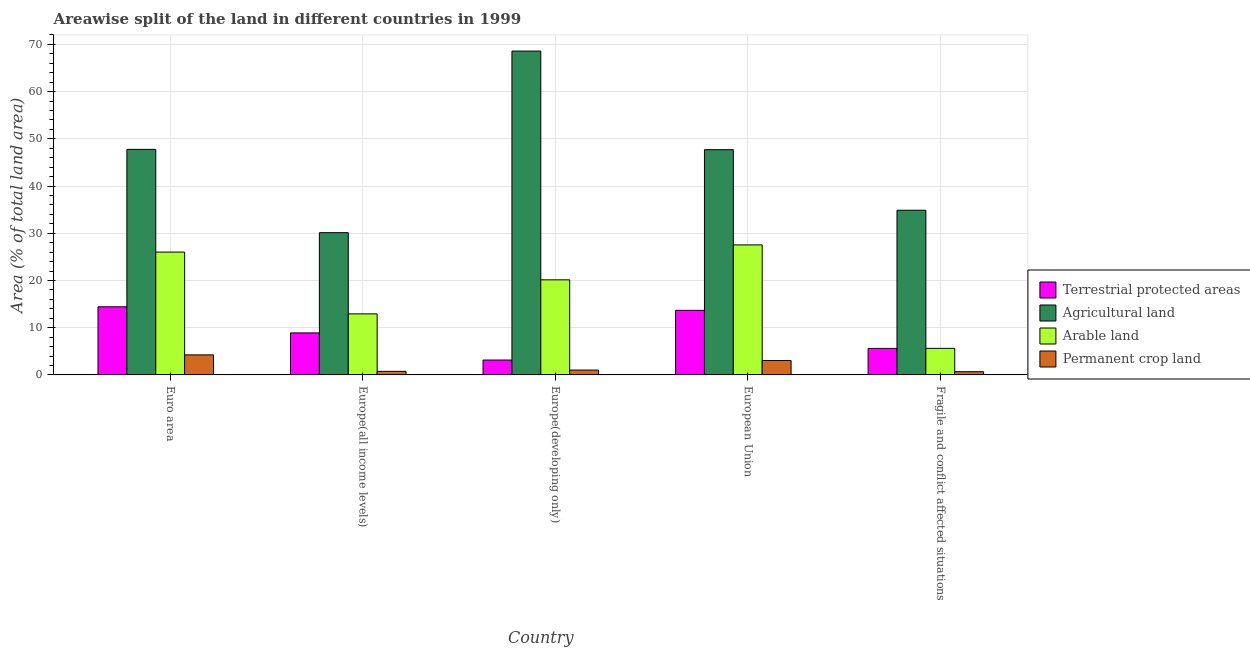How many bars are there on the 1st tick from the right?
Provide a short and direct response. 4. What is the label of the 4th group of bars from the left?
Keep it short and to the point. European Union. In how many cases, is the number of bars for a given country not equal to the number of legend labels?
Provide a succinct answer. 0. What is the percentage of area under agricultural land in Europe(all income levels)?
Provide a succinct answer. 30.12. Across all countries, what is the maximum percentage of area under agricultural land?
Provide a succinct answer. 68.58. Across all countries, what is the minimum percentage of area under permanent crop land?
Your response must be concise. 0.68. In which country was the percentage of area under agricultural land maximum?
Provide a succinct answer. Europe(developing only). In which country was the percentage of land under terrestrial protection minimum?
Your response must be concise. Europe(developing only). What is the total percentage of land under terrestrial protection in the graph?
Your answer should be compact. 45.75. What is the difference between the percentage of area under arable land in Europe(developing only) and that in European Union?
Keep it short and to the point. -7.4. What is the difference between the percentage of area under agricultural land in Euro area and the percentage of area under arable land in Europe(developing only)?
Offer a very short reply. 27.63. What is the average percentage of area under agricultural land per country?
Offer a very short reply. 45.81. What is the difference between the percentage of area under arable land and percentage of area under agricultural land in Europe(all income levels)?
Provide a short and direct response. -17.2. In how many countries, is the percentage of area under permanent crop land greater than 62 %?
Ensure brevity in your answer.  0. What is the ratio of the percentage of area under arable land in European Union to that in Fragile and conflict affected situations?
Keep it short and to the point. 4.89. Is the difference between the percentage of area under agricultural land in Europe(all income levels) and Fragile and conflict affected situations greater than the difference between the percentage of area under arable land in Europe(all income levels) and Fragile and conflict affected situations?
Your response must be concise. No. What is the difference between the highest and the second highest percentage of area under agricultural land?
Offer a terse response. 20.82. What is the difference between the highest and the lowest percentage of area under arable land?
Ensure brevity in your answer.  21.9. In how many countries, is the percentage of area under agricultural land greater than the average percentage of area under agricultural land taken over all countries?
Make the answer very short. 3. Is the sum of the percentage of area under agricultural land in Euro area and Fragile and conflict affected situations greater than the maximum percentage of area under permanent crop land across all countries?
Offer a very short reply. Yes. Is it the case that in every country, the sum of the percentage of area under agricultural land and percentage of land under terrestrial protection is greater than the sum of percentage of area under arable land and percentage of area under permanent crop land?
Your answer should be compact. Yes. What does the 1st bar from the left in Fragile and conflict affected situations represents?
Your response must be concise. Terrestrial protected areas. What does the 4th bar from the right in Fragile and conflict affected situations represents?
Keep it short and to the point. Terrestrial protected areas. Is it the case that in every country, the sum of the percentage of land under terrestrial protection and percentage of area under agricultural land is greater than the percentage of area under arable land?
Your response must be concise. Yes. Are all the bars in the graph horizontal?
Make the answer very short. No. What is the difference between two consecutive major ticks on the Y-axis?
Make the answer very short. 10. Are the values on the major ticks of Y-axis written in scientific E-notation?
Ensure brevity in your answer.  No. Does the graph contain grids?
Offer a terse response. Yes. Where does the legend appear in the graph?
Make the answer very short. Center right. How many legend labels are there?
Offer a terse response. 4. How are the legend labels stacked?
Keep it short and to the point. Vertical. What is the title of the graph?
Provide a succinct answer. Areawise split of the land in different countries in 1999. Does "Tertiary schools" appear as one of the legend labels in the graph?
Give a very brief answer. No. What is the label or title of the X-axis?
Offer a terse response. Country. What is the label or title of the Y-axis?
Give a very brief answer. Area (% of total land area). What is the Area (% of total land area) in Terrestrial protected areas in Euro area?
Your answer should be very brief. 14.42. What is the Area (% of total land area) in Agricultural land in Euro area?
Give a very brief answer. 47.76. What is the Area (% of total land area) of Arable land in Euro area?
Offer a very short reply. 26.01. What is the Area (% of total land area) of Permanent crop land in Euro area?
Keep it short and to the point. 4.24. What is the Area (% of total land area) of Terrestrial protected areas in Europe(all income levels)?
Provide a short and direct response. 8.89. What is the Area (% of total land area) of Agricultural land in Europe(all income levels)?
Provide a succinct answer. 30.12. What is the Area (% of total land area) of Arable land in Europe(all income levels)?
Offer a terse response. 12.92. What is the Area (% of total land area) of Permanent crop land in Europe(all income levels)?
Your answer should be very brief. 0.75. What is the Area (% of total land area) in Terrestrial protected areas in Europe(developing only)?
Your answer should be compact. 3.15. What is the Area (% of total land area) of Agricultural land in Europe(developing only)?
Keep it short and to the point. 68.58. What is the Area (% of total land area) in Arable land in Europe(developing only)?
Your answer should be very brief. 20.13. What is the Area (% of total land area) in Permanent crop land in Europe(developing only)?
Give a very brief answer. 1.03. What is the Area (% of total land area) of Terrestrial protected areas in European Union?
Your answer should be compact. 13.68. What is the Area (% of total land area) of Agricultural land in European Union?
Make the answer very short. 47.7. What is the Area (% of total land area) of Arable land in European Union?
Keep it short and to the point. 27.53. What is the Area (% of total land area) of Permanent crop land in European Union?
Give a very brief answer. 3.05. What is the Area (% of total land area) in Terrestrial protected areas in Fragile and conflict affected situations?
Offer a terse response. 5.61. What is the Area (% of total land area) of Agricultural land in Fragile and conflict affected situations?
Offer a terse response. 34.87. What is the Area (% of total land area) in Arable land in Fragile and conflict affected situations?
Offer a terse response. 5.63. What is the Area (% of total land area) in Permanent crop land in Fragile and conflict affected situations?
Ensure brevity in your answer.  0.68. Across all countries, what is the maximum Area (% of total land area) of Terrestrial protected areas?
Offer a terse response. 14.42. Across all countries, what is the maximum Area (% of total land area) of Agricultural land?
Give a very brief answer. 68.58. Across all countries, what is the maximum Area (% of total land area) in Arable land?
Ensure brevity in your answer.  27.53. Across all countries, what is the maximum Area (% of total land area) of Permanent crop land?
Keep it short and to the point. 4.24. Across all countries, what is the minimum Area (% of total land area) of Terrestrial protected areas?
Keep it short and to the point. 3.15. Across all countries, what is the minimum Area (% of total land area) of Agricultural land?
Make the answer very short. 30.12. Across all countries, what is the minimum Area (% of total land area) in Arable land?
Your answer should be very brief. 5.63. Across all countries, what is the minimum Area (% of total land area) in Permanent crop land?
Provide a succinct answer. 0.68. What is the total Area (% of total land area) in Terrestrial protected areas in the graph?
Provide a short and direct response. 45.75. What is the total Area (% of total land area) in Agricultural land in the graph?
Give a very brief answer. 229.03. What is the total Area (% of total land area) of Arable land in the graph?
Your answer should be very brief. 92.22. What is the total Area (% of total land area) in Permanent crop land in the graph?
Provide a short and direct response. 9.75. What is the difference between the Area (% of total land area) of Terrestrial protected areas in Euro area and that in Europe(all income levels)?
Your response must be concise. 5.53. What is the difference between the Area (% of total land area) in Agricultural land in Euro area and that in Europe(all income levels)?
Provide a short and direct response. 17.63. What is the difference between the Area (% of total land area) of Arable land in Euro area and that in Europe(all income levels)?
Offer a terse response. 13.09. What is the difference between the Area (% of total land area) in Permanent crop land in Euro area and that in Europe(all income levels)?
Your response must be concise. 3.49. What is the difference between the Area (% of total land area) of Terrestrial protected areas in Euro area and that in Europe(developing only)?
Make the answer very short. 11.27. What is the difference between the Area (% of total land area) of Agricultural land in Euro area and that in Europe(developing only)?
Give a very brief answer. -20.82. What is the difference between the Area (% of total land area) in Arable land in Euro area and that in Europe(developing only)?
Offer a very short reply. 5.88. What is the difference between the Area (% of total land area) in Permanent crop land in Euro area and that in Europe(developing only)?
Keep it short and to the point. 3.22. What is the difference between the Area (% of total land area) in Terrestrial protected areas in Euro area and that in European Union?
Provide a succinct answer. 0.75. What is the difference between the Area (% of total land area) of Agricultural land in Euro area and that in European Union?
Provide a succinct answer. 0.06. What is the difference between the Area (% of total land area) in Arable land in Euro area and that in European Union?
Your answer should be compact. -1.52. What is the difference between the Area (% of total land area) in Permanent crop land in Euro area and that in European Union?
Ensure brevity in your answer.  1.19. What is the difference between the Area (% of total land area) in Terrestrial protected areas in Euro area and that in Fragile and conflict affected situations?
Your answer should be very brief. 8.81. What is the difference between the Area (% of total land area) of Agricultural land in Euro area and that in Fragile and conflict affected situations?
Your answer should be compact. 12.89. What is the difference between the Area (% of total land area) of Arable land in Euro area and that in Fragile and conflict affected situations?
Keep it short and to the point. 20.39. What is the difference between the Area (% of total land area) in Permanent crop land in Euro area and that in Fragile and conflict affected situations?
Provide a short and direct response. 3.56. What is the difference between the Area (% of total land area) of Terrestrial protected areas in Europe(all income levels) and that in Europe(developing only)?
Make the answer very short. 5.74. What is the difference between the Area (% of total land area) in Agricultural land in Europe(all income levels) and that in Europe(developing only)?
Your response must be concise. -38.46. What is the difference between the Area (% of total land area) of Arable land in Europe(all income levels) and that in Europe(developing only)?
Keep it short and to the point. -7.21. What is the difference between the Area (% of total land area) in Permanent crop land in Europe(all income levels) and that in Europe(developing only)?
Offer a terse response. -0.27. What is the difference between the Area (% of total land area) in Terrestrial protected areas in Europe(all income levels) and that in European Union?
Your answer should be very brief. -4.78. What is the difference between the Area (% of total land area) in Agricultural land in Europe(all income levels) and that in European Union?
Make the answer very short. -17.57. What is the difference between the Area (% of total land area) of Arable land in Europe(all income levels) and that in European Union?
Keep it short and to the point. -14.61. What is the difference between the Area (% of total land area) of Permanent crop land in Europe(all income levels) and that in European Union?
Keep it short and to the point. -2.29. What is the difference between the Area (% of total land area) in Terrestrial protected areas in Europe(all income levels) and that in Fragile and conflict affected situations?
Your answer should be very brief. 3.28. What is the difference between the Area (% of total land area) of Agricultural land in Europe(all income levels) and that in Fragile and conflict affected situations?
Give a very brief answer. -4.75. What is the difference between the Area (% of total land area) of Arable land in Europe(all income levels) and that in Fragile and conflict affected situations?
Provide a succinct answer. 7.3. What is the difference between the Area (% of total land area) of Permanent crop land in Europe(all income levels) and that in Fragile and conflict affected situations?
Ensure brevity in your answer.  0.08. What is the difference between the Area (% of total land area) in Terrestrial protected areas in Europe(developing only) and that in European Union?
Offer a terse response. -10.52. What is the difference between the Area (% of total land area) of Agricultural land in Europe(developing only) and that in European Union?
Provide a short and direct response. 20.88. What is the difference between the Area (% of total land area) in Arable land in Europe(developing only) and that in European Union?
Keep it short and to the point. -7.4. What is the difference between the Area (% of total land area) of Permanent crop land in Europe(developing only) and that in European Union?
Your answer should be compact. -2.02. What is the difference between the Area (% of total land area) of Terrestrial protected areas in Europe(developing only) and that in Fragile and conflict affected situations?
Ensure brevity in your answer.  -2.46. What is the difference between the Area (% of total land area) of Agricultural land in Europe(developing only) and that in Fragile and conflict affected situations?
Give a very brief answer. 33.71. What is the difference between the Area (% of total land area) in Arable land in Europe(developing only) and that in Fragile and conflict affected situations?
Give a very brief answer. 14.51. What is the difference between the Area (% of total land area) in Permanent crop land in Europe(developing only) and that in Fragile and conflict affected situations?
Ensure brevity in your answer.  0.35. What is the difference between the Area (% of total land area) in Terrestrial protected areas in European Union and that in Fragile and conflict affected situations?
Make the answer very short. 8.06. What is the difference between the Area (% of total land area) of Agricultural land in European Union and that in Fragile and conflict affected situations?
Provide a succinct answer. 12.83. What is the difference between the Area (% of total land area) of Arable land in European Union and that in Fragile and conflict affected situations?
Give a very brief answer. 21.9. What is the difference between the Area (% of total land area) of Permanent crop land in European Union and that in Fragile and conflict affected situations?
Offer a very short reply. 2.37. What is the difference between the Area (% of total land area) of Terrestrial protected areas in Euro area and the Area (% of total land area) of Agricultural land in Europe(all income levels)?
Offer a very short reply. -15.7. What is the difference between the Area (% of total land area) of Terrestrial protected areas in Euro area and the Area (% of total land area) of Permanent crop land in Europe(all income levels)?
Offer a terse response. 13.67. What is the difference between the Area (% of total land area) in Agricultural land in Euro area and the Area (% of total land area) in Arable land in Europe(all income levels)?
Offer a very short reply. 34.84. What is the difference between the Area (% of total land area) of Agricultural land in Euro area and the Area (% of total land area) of Permanent crop land in Europe(all income levels)?
Offer a terse response. 47.01. What is the difference between the Area (% of total land area) in Arable land in Euro area and the Area (% of total land area) in Permanent crop land in Europe(all income levels)?
Provide a short and direct response. 25.26. What is the difference between the Area (% of total land area) of Terrestrial protected areas in Euro area and the Area (% of total land area) of Agricultural land in Europe(developing only)?
Offer a very short reply. -54.16. What is the difference between the Area (% of total land area) in Terrestrial protected areas in Euro area and the Area (% of total land area) in Arable land in Europe(developing only)?
Make the answer very short. -5.71. What is the difference between the Area (% of total land area) in Terrestrial protected areas in Euro area and the Area (% of total land area) in Permanent crop land in Europe(developing only)?
Your answer should be very brief. 13.4. What is the difference between the Area (% of total land area) in Agricultural land in Euro area and the Area (% of total land area) in Arable land in Europe(developing only)?
Make the answer very short. 27.63. What is the difference between the Area (% of total land area) of Agricultural land in Euro area and the Area (% of total land area) of Permanent crop land in Europe(developing only)?
Ensure brevity in your answer.  46.73. What is the difference between the Area (% of total land area) of Arable land in Euro area and the Area (% of total land area) of Permanent crop land in Europe(developing only)?
Keep it short and to the point. 24.99. What is the difference between the Area (% of total land area) of Terrestrial protected areas in Euro area and the Area (% of total land area) of Agricultural land in European Union?
Your response must be concise. -33.28. What is the difference between the Area (% of total land area) of Terrestrial protected areas in Euro area and the Area (% of total land area) of Arable land in European Union?
Make the answer very short. -13.11. What is the difference between the Area (% of total land area) of Terrestrial protected areas in Euro area and the Area (% of total land area) of Permanent crop land in European Union?
Ensure brevity in your answer.  11.37. What is the difference between the Area (% of total land area) of Agricultural land in Euro area and the Area (% of total land area) of Arable land in European Union?
Keep it short and to the point. 20.23. What is the difference between the Area (% of total land area) of Agricultural land in Euro area and the Area (% of total land area) of Permanent crop land in European Union?
Give a very brief answer. 44.71. What is the difference between the Area (% of total land area) of Arable land in Euro area and the Area (% of total land area) of Permanent crop land in European Union?
Your response must be concise. 22.96. What is the difference between the Area (% of total land area) in Terrestrial protected areas in Euro area and the Area (% of total land area) in Agricultural land in Fragile and conflict affected situations?
Ensure brevity in your answer.  -20.45. What is the difference between the Area (% of total land area) in Terrestrial protected areas in Euro area and the Area (% of total land area) in Arable land in Fragile and conflict affected situations?
Ensure brevity in your answer.  8.8. What is the difference between the Area (% of total land area) of Terrestrial protected areas in Euro area and the Area (% of total land area) of Permanent crop land in Fragile and conflict affected situations?
Give a very brief answer. 13.74. What is the difference between the Area (% of total land area) of Agricultural land in Euro area and the Area (% of total land area) of Arable land in Fragile and conflict affected situations?
Provide a short and direct response. 42.13. What is the difference between the Area (% of total land area) in Agricultural land in Euro area and the Area (% of total land area) in Permanent crop land in Fragile and conflict affected situations?
Provide a short and direct response. 47.08. What is the difference between the Area (% of total land area) of Arable land in Euro area and the Area (% of total land area) of Permanent crop land in Fragile and conflict affected situations?
Ensure brevity in your answer.  25.33. What is the difference between the Area (% of total land area) in Terrestrial protected areas in Europe(all income levels) and the Area (% of total land area) in Agricultural land in Europe(developing only)?
Your answer should be very brief. -59.69. What is the difference between the Area (% of total land area) of Terrestrial protected areas in Europe(all income levels) and the Area (% of total land area) of Arable land in Europe(developing only)?
Make the answer very short. -11.24. What is the difference between the Area (% of total land area) in Terrestrial protected areas in Europe(all income levels) and the Area (% of total land area) in Permanent crop land in Europe(developing only)?
Keep it short and to the point. 7.87. What is the difference between the Area (% of total land area) of Agricultural land in Europe(all income levels) and the Area (% of total land area) of Arable land in Europe(developing only)?
Provide a succinct answer. 9.99. What is the difference between the Area (% of total land area) in Agricultural land in Europe(all income levels) and the Area (% of total land area) in Permanent crop land in Europe(developing only)?
Your answer should be compact. 29.1. What is the difference between the Area (% of total land area) of Arable land in Europe(all income levels) and the Area (% of total land area) of Permanent crop land in Europe(developing only)?
Offer a very short reply. 11.9. What is the difference between the Area (% of total land area) in Terrestrial protected areas in Europe(all income levels) and the Area (% of total land area) in Agricultural land in European Union?
Your response must be concise. -38.81. What is the difference between the Area (% of total land area) of Terrestrial protected areas in Europe(all income levels) and the Area (% of total land area) of Arable land in European Union?
Offer a very short reply. -18.64. What is the difference between the Area (% of total land area) of Terrestrial protected areas in Europe(all income levels) and the Area (% of total land area) of Permanent crop land in European Union?
Provide a succinct answer. 5.84. What is the difference between the Area (% of total land area) in Agricultural land in Europe(all income levels) and the Area (% of total land area) in Arable land in European Union?
Give a very brief answer. 2.6. What is the difference between the Area (% of total land area) of Agricultural land in Europe(all income levels) and the Area (% of total land area) of Permanent crop land in European Union?
Make the answer very short. 27.08. What is the difference between the Area (% of total land area) in Arable land in Europe(all income levels) and the Area (% of total land area) in Permanent crop land in European Union?
Offer a terse response. 9.87. What is the difference between the Area (% of total land area) of Terrestrial protected areas in Europe(all income levels) and the Area (% of total land area) of Agricultural land in Fragile and conflict affected situations?
Give a very brief answer. -25.98. What is the difference between the Area (% of total land area) in Terrestrial protected areas in Europe(all income levels) and the Area (% of total land area) in Arable land in Fragile and conflict affected situations?
Your answer should be compact. 3.27. What is the difference between the Area (% of total land area) in Terrestrial protected areas in Europe(all income levels) and the Area (% of total land area) in Permanent crop land in Fragile and conflict affected situations?
Your answer should be very brief. 8.22. What is the difference between the Area (% of total land area) of Agricultural land in Europe(all income levels) and the Area (% of total land area) of Arable land in Fragile and conflict affected situations?
Provide a short and direct response. 24.5. What is the difference between the Area (% of total land area) of Agricultural land in Europe(all income levels) and the Area (% of total land area) of Permanent crop land in Fragile and conflict affected situations?
Keep it short and to the point. 29.45. What is the difference between the Area (% of total land area) in Arable land in Europe(all income levels) and the Area (% of total land area) in Permanent crop land in Fragile and conflict affected situations?
Provide a short and direct response. 12.24. What is the difference between the Area (% of total land area) of Terrestrial protected areas in Europe(developing only) and the Area (% of total land area) of Agricultural land in European Union?
Your answer should be compact. -44.55. What is the difference between the Area (% of total land area) in Terrestrial protected areas in Europe(developing only) and the Area (% of total land area) in Arable land in European Union?
Your answer should be very brief. -24.38. What is the difference between the Area (% of total land area) of Terrestrial protected areas in Europe(developing only) and the Area (% of total land area) of Permanent crop land in European Union?
Offer a very short reply. 0.1. What is the difference between the Area (% of total land area) of Agricultural land in Europe(developing only) and the Area (% of total land area) of Arable land in European Union?
Provide a short and direct response. 41.05. What is the difference between the Area (% of total land area) of Agricultural land in Europe(developing only) and the Area (% of total land area) of Permanent crop land in European Union?
Provide a short and direct response. 65.53. What is the difference between the Area (% of total land area) of Arable land in Europe(developing only) and the Area (% of total land area) of Permanent crop land in European Union?
Keep it short and to the point. 17.08. What is the difference between the Area (% of total land area) in Terrestrial protected areas in Europe(developing only) and the Area (% of total land area) in Agricultural land in Fragile and conflict affected situations?
Keep it short and to the point. -31.72. What is the difference between the Area (% of total land area) in Terrestrial protected areas in Europe(developing only) and the Area (% of total land area) in Arable land in Fragile and conflict affected situations?
Keep it short and to the point. -2.48. What is the difference between the Area (% of total land area) in Terrestrial protected areas in Europe(developing only) and the Area (% of total land area) in Permanent crop land in Fragile and conflict affected situations?
Make the answer very short. 2.47. What is the difference between the Area (% of total land area) of Agricultural land in Europe(developing only) and the Area (% of total land area) of Arable land in Fragile and conflict affected situations?
Keep it short and to the point. 62.95. What is the difference between the Area (% of total land area) of Agricultural land in Europe(developing only) and the Area (% of total land area) of Permanent crop land in Fragile and conflict affected situations?
Ensure brevity in your answer.  67.9. What is the difference between the Area (% of total land area) of Arable land in Europe(developing only) and the Area (% of total land area) of Permanent crop land in Fragile and conflict affected situations?
Your response must be concise. 19.46. What is the difference between the Area (% of total land area) of Terrestrial protected areas in European Union and the Area (% of total land area) of Agricultural land in Fragile and conflict affected situations?
Your response must be concise. -21.2. What is the difference between the Area (% of total land area) in Terrestrial protected areas in European Union and the Area (% of total land area) in Arable land in Fragile and conflict affected situations?
Your response must be concise. 8.05. What is the difference between the Area (% of total land area) in Terrestrial protected areas in European Union and the Area (% of total land area) in Permanent crop land in Fragile and conflict affected situations?
Offer a terse response. 13. What is the difference between the Area (% of total land area) of Agricultural land in European Union and the Area (% of total land area) of Arable land in Fragile and conflict affected situations?
Provide a succinct answer. 42.07. What is the difference between the Area (% of total land area) in Agricultural land in European Union and the Area (% of total land area) in Permanent crop land in Fragile and conflict affected situations?
Offer a terse response. 47.02. What is the difference between the Area (% of total land area) in Arable land in European Union and the Area (% of total land area) in Permanent crop land in Fragile and conflict affected situations?
Your answer should be very brief. 26.85. What is the average Area (% of total land area) in Terrestrial protected areas per country?
Offer a terse response. 9.15. What is the average Area (% of total land area) of Agricultural land per country?
Offer a very short reply. 45.81. What is the average Area (% of total land area) of Arable land per country?
Offer a terse response. 18.44. What is the average Area (% of total land area) of Permanent crop land per country?
Provide a succinct answer. 1.95. What is the difference between the Area (% of total land area) in Terrestrial protected areas and Area (% of total land area) in Agricultural land in Euro area?
Your response must be concise. -33.34. What is the difference between the Area (% of total land area) in Terrestrial protected areas and Area (% of total land area) in Arable land in Euro area?
Ensure brevity in your answer.  -11.59. What is the difference between the Area (% of total land area) in Terrestrial protected areas and Area (% of total land area) in Permanent crop land in Euro area?
Your answer should be very brief. 10.18. What is the difference between the Area (% of total land area) of Agricultural land and Area (% of total land area) of Arable land in Euro area?
Offer a terse response. 21.75. What is the difference between the Area (% of total land area) in Agricultural land and Area (% of total land area) in Permanent crop land in Euro area?
Your answer should be very brief. 43.52. What is the difference between the Area (% of total land area) in Arable land and Area (% of total land area) in Permanent crop land in Euro area?
Provide a succinct answer. 21.77. What is the difference between the Area (% of total land area) of Terrestrial protected areas and Area (% of total land area) of Agricultural land in Europe(all income levels)?
Ensure brevity in your answer.  -21.23. What is the difference between the Area (% of total land area) of Terrestrial protected areas and Area (% of total land area) of Arable land in Europe(all income levels)?
Offer a very short reply. -4.03. What is the difference between the Area (% of total land area) in Terrestrial protected areas and Area (% of total land area) in Permanent crop land in Europe(all income levels)?
Your response must be concise. 8.14. What is the difference between the Area (% of total land area) of Agricultural land and Area (% of total land area) of Arable land in Europe(all income levels)?
Provide a short and direct response. 17.2. What is the difference between the Area (% of total land area) in Agricultural land and Area (% of total land area) in Permanent crop land in Europe(all income levels)?
Offer a very short reply. 29.37. What is the difference between the Area (% of total land area) in Arable land and Area (% of total land area) in Permanent crop land in Europe(all income levels)?
Keep it short and to the point. 12.17. What is the difference between the Area (% of total land area) of Terrestrial protected areas and Area (% of total land area) of Agricultural land in Europe(developing only)?
Ensure brevity in your answer.  -65.43. What is the difference between the Area (% of total land area) of Terrestrial protected areas and Area (% of total land area) of Arable land in Europe(developing only)?
Make the answer very short. -16.98. What is the difference between the Area (% of total land area) in Terrestrial protected areas and Area (% of total land area) in Permanent crop land in Europe(developing only)?
Your answer should be compact. 2.12. What is the difference between the Area (% of total land area) in Agricultural land and Area (% of total land area) in Arable land in Europe(developing only)?
Provide a short and direct response. 48.45. What is the difference between the Area (% of total land area) in Agricultural land and Area (% of total land area) in Permanent crop land in Europe(developing only)?
Provide a short and direct response. 67.55. What is the difference between the Area (% of total land area) in Arable land and Area (% of total land area) in Permanent crop land in Europe(developing only)?
Your answer should be very brief. 19.11. What is the difference between the Area (% of total land area) of Terrestrial protected areas and Area (% of total land area) of Agricultural land in European Union?
Your answer should be very brief. -34.02. What is the difference between the Area (% of total land area) of Terrestrial protected areas and Area (% of total land area) of Arable land in European Union?
Ensure brevity in your answer.  -13.85. What is the difference between the Area (% of total land area) of Terrestrial protected areas and Area (% of total land area) of Permanent crop land in European Union?
Make the answer very short. 10.63. What is the difference between the Area (% of total land area) in Agricultural land and Area (% of total land area) in Arable land in European Union?
Your response must be concise. 20.17. What is the difference between the Area (% of total land area) in Agricultural land and Area (% of total land area) in Permanent crop land in European Union?
Your response must be concise. 44.65. What is the difference between the Area (% of total land area) of Arable land and Area (% of total land area) of Permanent crop land in European Union?
Your response must be concise. 24.48. What is the difference between the Area (% of total land area) in Terrestrial protected areas and Area (% of total land area) in Agricultural land in Fragile and conflict affected situations?
Keep it short and to the point. -29.26. What is the difference between the Area (% of total land area) in Terrestrial protected areas and Area (% of total land area) in Arable land in Fragile and conflict affected situations?
Offer a terse response. -0.01. What is the difference between the Area (% of total land area) in Terrestrial protected areas and Area (% of total land area) in Permanent crop land in Fragile and conflict affected situations?
Offer a terse response. 4.94. What is the difference between the Area (% of total land area) of Agricultural land and Area (% of total land area) of Arable land in Fragile and conflict affected situations?
Your answer should be very brief. 29.24. What is the difference between the Area (% of total land area) in Agricultural land and Area (% of total land area) in Permanent crop land in Fragile and conflict affected situations?
Ensure brevity in your answer.  34.19. What is the difference between the Area (% of total land area) in Arable land and Area (% of total land area) in Permanent crop land in Fragile and conflict affected situations?
Give a very brief answer. 4.95. What is the ratio of the Area (% of total land area) in Terrestrial protected areas in Euro area to that in Europe(all income levels)?
Make the answer very short. 1.62. What is the ratio of the Area (% of total land area) of Agricultural land in Euro area to that in Europe(all income levels)?
Provide a succinct answer. 1.59. What is the ratio of the Area (% of total land area) in Arable land in Euro area to that in Europe(all income levels)?
Ensure brevity in your answer.  2.01. What is the ratio of the Area (% of total land area) of Permanent crop land in Euro area to that in Europe(all income levels)?
Your answer should be very brief. 5.62. What is the ratio of the Area (% of total land area) in Terrestrial protected areas in Euro area to that in Europe(developing only)?
Provide a short and direct response. 4.58. What is the ratio of the Area (% of total land area) in Agricultural land in Euro area to that in Europe(developing only)?
Provide a short and direct response. 0.7. What is the ratio of the Area (% of total land area) in Arable land in Euro area to that in Europe(developing only)?
Provide a succinct answer. 1.29. What is the ratio of the Area (% of total land area) of Permanent crop land in Euro area to that in Europe(developing only)?
Your answer should be compact. 4.13. What is the ratio of the Area (% of total land area) of Terrestrial protected areas in Euro area to that in European Union?
Your answer should be very brief. 1.05. What is the ratio of the Area (% of total land area) of Agricultural land in Euro area to that in European Union?
Ensure brevity in your answer.  1. What is the ratio of the Area (% of total land area) of Arable land in Euro area to that in European Union?
Your response must be concise. 0.94. What is the ratio of the Area (% of total land area) in Permanent crop land in Euro area to that in European Union?
Offer a terse response. 1.39. What is the ratio of the Area (% of total land area) in Terrestrial protected areas in Euro area to that in Fragile and conflict affected situations?
Offer a terse response. 2.57. What is the ratio of the Area (% of total land area) of Agricultural land in Euro area to that in Fragile and conflict affected situations?
Provide a succinct answer. 1.37. What is the ratio of the Area (% of total land area) in Arable land in Euro area to that in Fragile and conflict affected situations?
Your answer should be compact. 4.62. What is the ratio of the Area (% of total land area) of Permanent crop land in Euro area to that in Fragile and conflict affected situations?
Ensure brevity in your answer.  6.26. What is the ratio of the Area (% of total land area) of Terrestrial protected areas in Europe(all income levels) to that in Europe(developing only)?
Make the answer very short. 2.82. What is the ratio of the Area (% of total land area) of Agricultural land in Europe(all income levels) to that in Europe(developing only)?
Your answer should be compact. 0.44. What is the ratio of the Area (% of total land area) of Arable land in Europe(all income levels) to that in Europe(developing only)?
Your answer should be compact. 0.64. What is the ratio of the Area (% of total land area) of Permanent crop land in Europe(all income levels) to that in Europe(developing only)?
Offer a very short reply. 0.73. What is the ratio of the Area (% of total land area) of Terrestrial protected areas in Europe(all income levels) to that in European Union?
Provide a short and direct response. 0.65. What is the ratio of the Area (% of total land area) of Agricultural land in Europe(all income levels) to that in European Union?
Ensure brevity in your answer.  0.63. What is the ratio of the Area (% of total land area) of Arable land in Europe(all income levels) to that in European Union?
Your response must be concise. 0.47. What is the ratio of the Area (% of total land area) of Permanent crop land in Europe(all income levels) to that in European Union?
Offer a very short reply. 0.25. What is the ratio of the Area (% of total land area) of Terrestrial protected areas in Europe(all income levels) to that in Fragile and conflict affected situations?
Keep it short and to the point. 1.58. What is the ratio of the Area (% of total land area) of Agricultural land in Europe(all income levels) to that in Fragile and conflict affected situations?
Make the answer very short. 0.86. What is the ratio of the Area (% of total land area) in Arable land in Europe(all income levels) to that in Fragile and conflict affected situations?
Keep it short and to the point. 2.3. What is the ratio of the Area (% of total land area) of Permanent crop land in Europe(all income levels) to that in Fragile and conflict affected situations?
Ensure brevity in your answer.  1.11. What is the ratio of the Area (% of total land area) in Terrestrial protected areas in Europe(developing only) to that in European Union?
Ensure brevity in your answer.  0.23. What is the ratio of the Area (% of total land area) in Agricultural land in Europe(developing only) to that in European Union?
Provide a succinct answer. 1.44. What is the ratio of the Area (% of total land area) of Arable land in Europe(developing only) to that in European Union?
Your answer should be compact. 0.73. What is the ratio of the Area (% of total land area) of Permanent crop land in Europe(developing only) to that in European Union?
Give a very brief answer. 0.34. What is the ratio of the Area (% of total land area) of Terrestrial protected areas in Europe(developing only) to that in Fragile and conflict affected situations?
Offer a terse response. 0.56. What is the ratio of the Area (% of total land area) of Agricultural land in Europe(developing only) to that in Fragile and conflict affected situations?
Your answer should be compact. 1.97. What is the ratio of the Area (% of total land area) in Arable land in Europe(developing only) to that in Fragile and conflict affected situations?
Offer a very short reply. 3.58. What is the ratio of the Area (% of total land area) in Permanent crop land in Europe(developing only) to that in Fragile and conflict affected situations?
Offer a very short reply. 1.51. What is the ratio of the Area (% of total land area) in Terrestrial protected areas in European Union to that in Fragile and conflict affected situations?
Provide a short and direct response. 2.44. What is the ratio of the Area (% of total land area) in Agricultural land in European Union to that in Fragile and conflict affected situations?
Offer a terse response. 1.37. What is the ratio of the Area (% of total land area) in Arable land in European Union to that in Fragile and conflict affected situations?
Offer a very short reply. 4.89. What is the ratio of the Area (% of total land area) of Permanent crop land in European Union to that in Fragile and conflict affected situations?
Provide a short and direct response. 4.5. What is the difference between the highest and the second highest Area (% of total land area) in Terrestrial protected areas?
Make the answer very short. 0.75. What is the difference between the highest and the second highest Area (% of total land area) in Agricultural land?
Offer a terse response. 20.82. What is the difference between the highest and the second highest Area (% of total land area) of Arable land?
Your answer should be compact. 1.52. What is the difference between the highest and the second highest Area (% of total land area) of Permanent crop land?
Your answer should be very brief. 1.19. What is the difference between the highest and the lowest Area (% of total land area) of Terrestrial protected areas?
Give a very brief answer. 11.27. What is the difference between the highest and the lowest Area (% of total land area) in Agricultural land?
Your answer should be very brief. 38.46. What is the difference between the highest and the lowest Area (% of total land area) of Arable land?
Make the answer very short. 21.9. What is the difference between the highest and the lowest Area (% of total land area) of Permanent crop land?
Offer a very short reply. 3.56. 